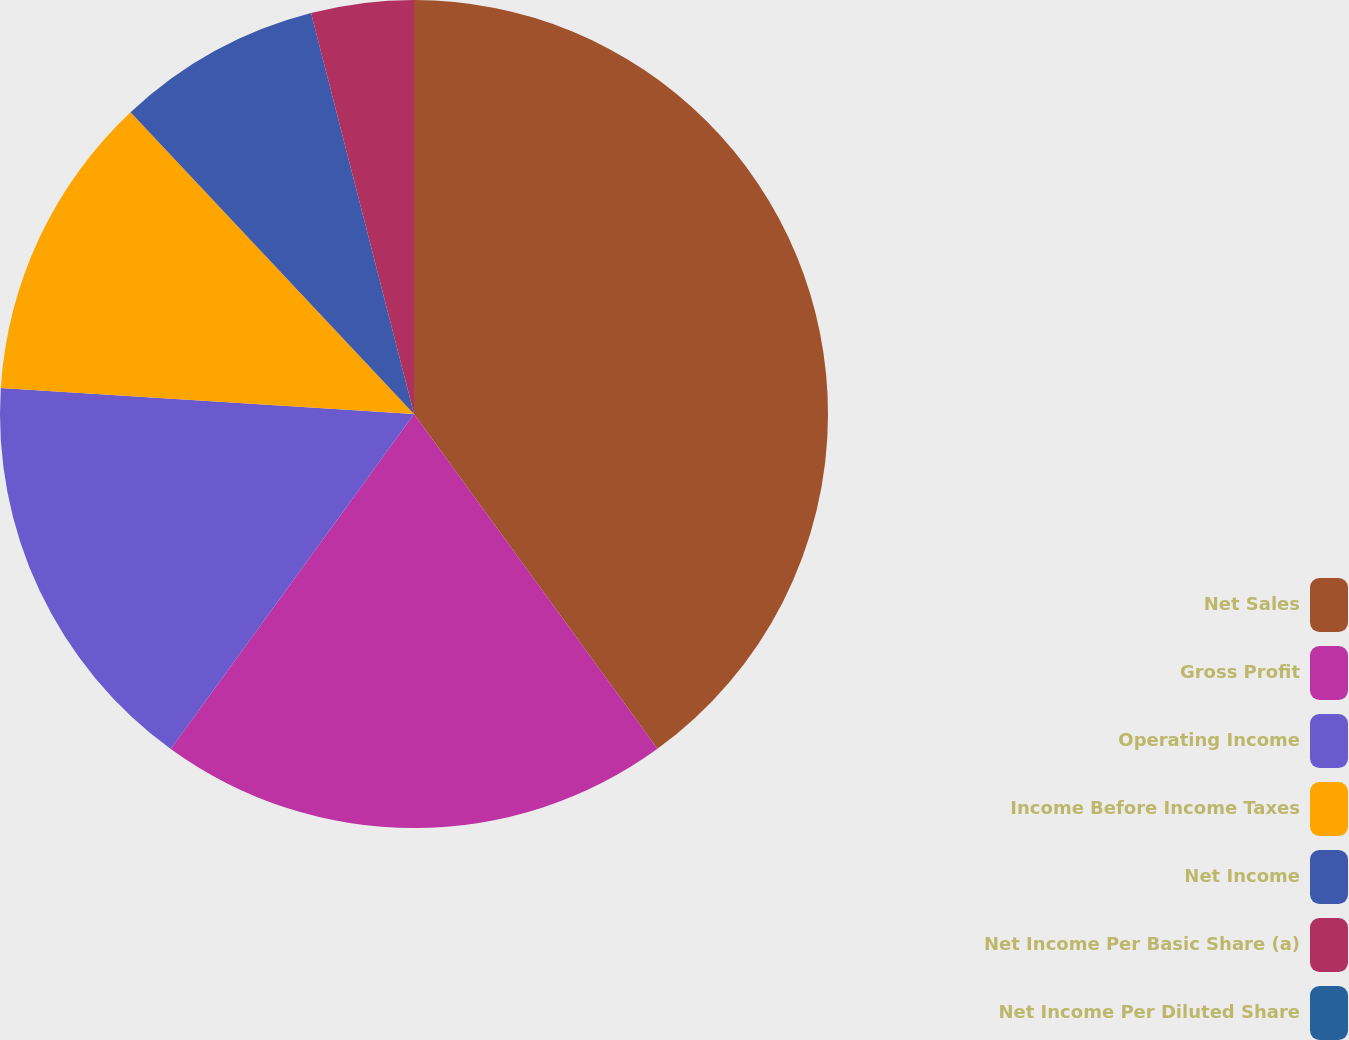Convert chart to OTSL. <chart><loc_0><loc_0><loc_500><loc_500><pie_chart><fcel>Net Sales<fcel>Gross Profit<fcel>Operating Income<fcel>Income Before Income Taxes<fcel>Net Income<fcel>Net Income Per Basic Share (a)<fcel>Net Income Per Diluted Share<nl><fcel>39.99%<fcel>20.0%<fcel>16.0%<fcel>12.0%<fcel>8.0%<fcel>4.0%<fcel>0.0%<nl></chart> 